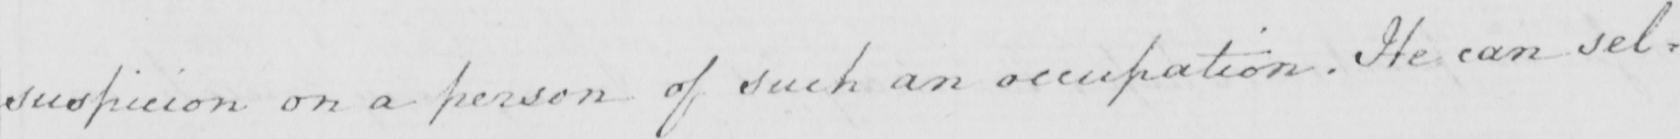Can you tell me what this handwritten text says? suspicion on a person of such an occupation . He can sel= 